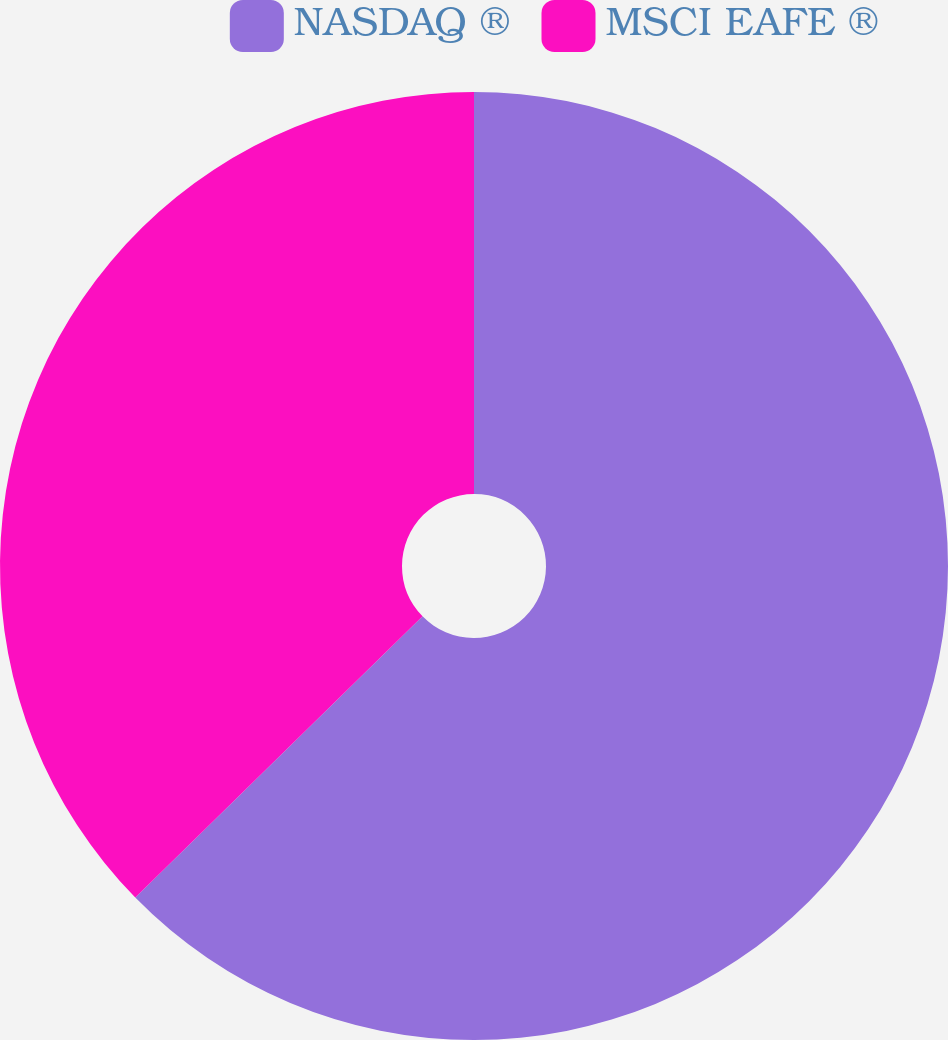<chart> <loc_0><loc_0><loc_500><loc_500><pie_chart><fcel>NASDAQ ®<fcel>MSCI EAFE ®<nl><fcel>62.67%<fcel>37.33%<nl></chart> 